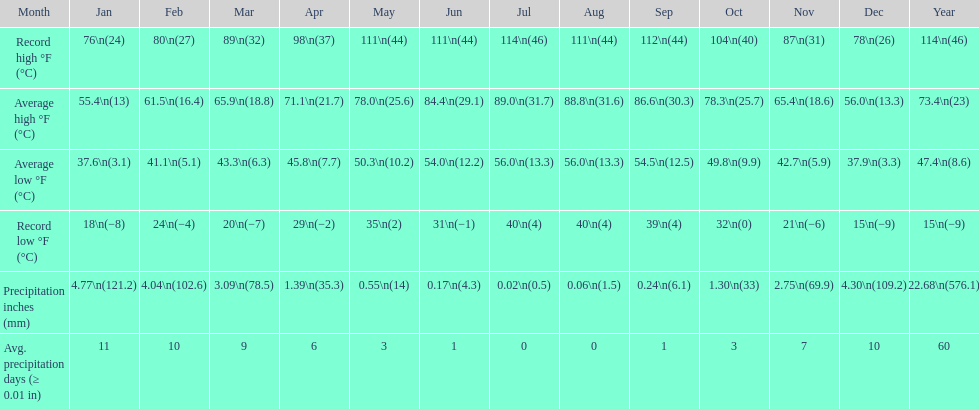0 degrees? July. 